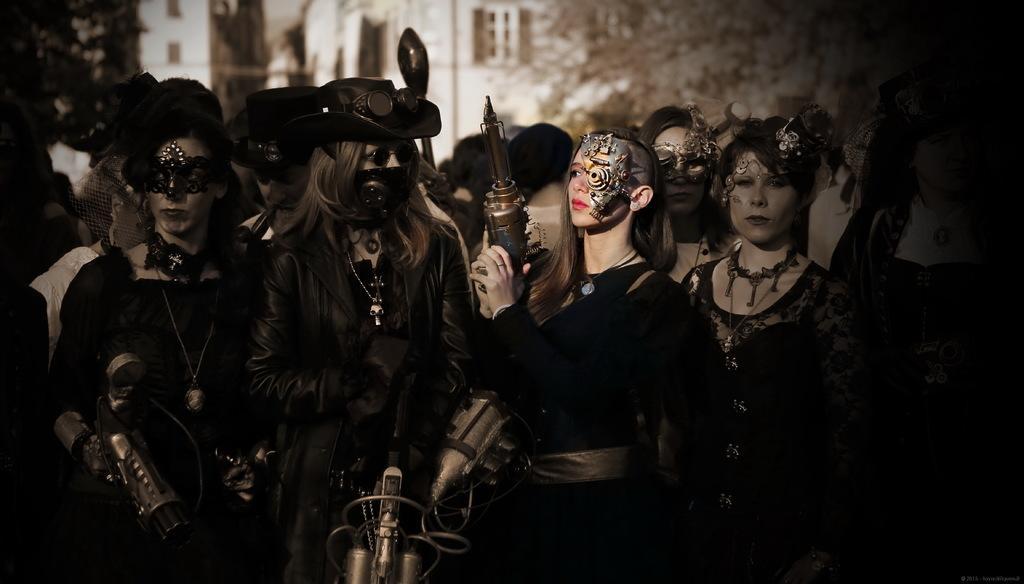In one or two sentences, can you explain what this image depicts? In this image I can see number of women wearing black colored dresses and face masks are standing and holding weapons in their hands. In the background I can see few buildings and few trees. 